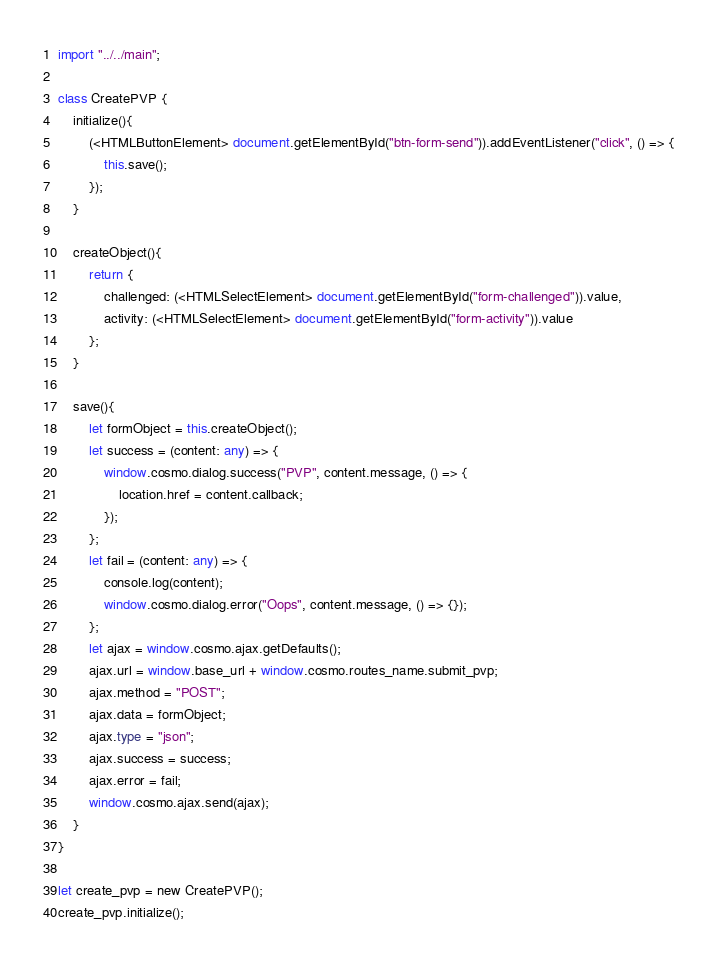Convert code to text. <code><loc_0><loc_0><loc_500><loc_500><_TypeScript_>import "../../main";

class CreatePVP {
    initialize(){
        (<HTMLButtonElement> document.getElementById("btn-form-send")).addEventListener("click", () => {
            this.save();
        });
    }

    createObject(){
        return {
            challenged: (<HTMLSelectElement> document.getElementById("form-challenged")).value,
            activity: (<HTMLSelectElement> document.getElementById("form-activity")).value
        };
    }

    save(){
        let formObject = this.createObject();
        let success = (content: any) => {
            window.cosmo.dialog.success("PVP", content.message, () => {
                location.href = content.callback;
            });
        };
        let fail = (content: any) => {
            console.log(content);
            window.cosmo.dialog.error("Oops", content.message, () => {});
        };
        let ajax = window.cosmo.ajax.getDefaults();
        ajax.url = window.base_url + window.cosmo.routes_name.submit_pvp;
        ajax.method = "POST";
        ajax.data = formObject;
        ajax.type = "json";
        ajax.success = success;
        ajax.error = fail;
        window.cosmo.ajax.send(ajax);
    }
}

let create_pvp = new CreatePVP();
create_pvp.initialize();</code> 